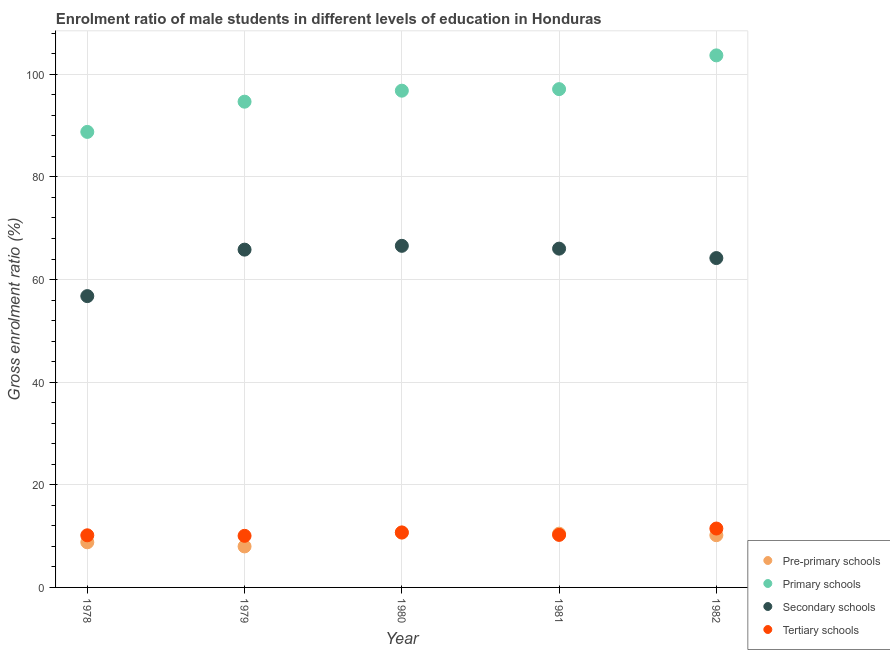How many different coloured dotlines are there?
Your response must be concise. 4. What is the gross enrolment ratio(female) in pre-primary schools in 1981?
Offer a terse response. 10.48. Across all years, what is the maximum gross enrolment ratio(female) in tertiary schools?
Provide a succinct answer. 11.48. Across all years, what is the minimum gross enrolment ratio(female) in pre-primary schools?
Provide a short and direct response. 7.99. In which year was the gross enrolment ratio(female) in primary schools minimum?
Your answer should be very brief. 1978. What is the total gross enrolment ratio(female) in tertiary schools in the graph?
Give a very brief answer. 52.64. What is the difference between the gross enrolment ratio(female) in secondary schools in 1980 and that in 1982?
Ensure brevity in your answer.  2.38. What is the difference between the gross enrolment ratio(female) in secondary schools in 1978 and the gross enrolment ratio(female) in pre-primary schools in 1980?
Your answer should be very brief. 46.09. What is the average gross enrolment ratio(female) in primary schools per year?
Your answer should be very brief. 96.21. In the year 1981, what is the difference between the gross enrolment ratio(female) in secondary schools and gross enrolment ratio(female) in primary schools?
Give a very brief answer. -31.09. In how many years, is the gross enrolment ratio(female) in pre-primary schools greater than 92 %?
Provide a succinct answer. 0. What is the ratio of the gross enrolment ratio(female) in pre-primary schools in 1980 to that in 1981?
Make the answer very short. 1.02. What is the difference between the highest and the second highest gross enrolment ratio(female) in tertiary schools?
Provide a short and direct response. 0.76. What is the difference between the highest and the lowest gross enrolment ratio(female) in tertiary schools?
Your response must be concise. 1.42. Is it the case that in every year, the sum of the gross enrolment ratio(female) in primary schools and gross enrolment ratio(female) in secondary schools is greater than the sum of gross enrolment ratio(female) in tertiary schools and gross enrolment ratio(female) in pre-primary schools?
Make the answer very short. Yes. Is it the case that in every year, the sum of the gross enrolment ratio(female) in pre-primary schools and gross enrolment ratio(female) in primary schools is greater than the gross enrolment ratio(female) in secondary schools?
Make the answer very short. Yes. Does the gross enrolment ratio(female) in pre-primary schools monotonically increase over the years?
Ensure brevity in your answer.  No. Is the gross enrolment ratio(female) in pre-primary schools strictly greater than the gross enrolment ratio(female) in primary schools over the years?
Provide a succinct answer. No. How many dotlines are there?
Give a very brief answer. 4. How many years are there in the graph?
Provide a succinct answer. 5. What is the difference between two consecutive major ticks on the Y-axis?
Keep it short and to the point. 20. Are the values on the major ticks of Y-axis written in scientific E-notation?
Make the answer very short. No. How many legend labels are there?
Keep it short and to the point. 4. What is the title of the graph?
Keep it short and to the point. Enrolment ratio of male students in different levels of education in Honduras. Does "Primary" appear as one of the legend labels in the graph?
Offer a very short reply. No. What is the label or title of the Y-axis?
Offer a very short reply. Gross enrolment ratio (%). What is the Gross enrolment ratio (%) of Pre-primary schools in 1978?
Offer a very short reply. 8.8. What is the Gross enrolment ratio (%) of Primary schools in 1978?
Offer a very short reply. 88.77. What is the Gross enrolment ratio (%) of Secondary schools in 1978?
Your response must be concise. 56.77. What is the Gross enrolment ratio (%) of Tertiary schools in 1978?
Your answer should be very brief. 10.16. What is the Gross enrolment ratio (%) in Pre-primary schools in 1979?
Give a very brief answer. 7.99. What is the Gross enrolment ratio (%) of Primary schools in 1979?
Offer a very short reply. 94.66. What is the Gross enrolment ratio (%) in Secondary schools in 1979?
Give a very brief answer. 65.83. What is the Gross enrolment ratio (%) in Tertiary schools in 1979?
Provide a succinct answer. 10.06. What is the Gross enrolment ratio (%) of Pre-primary schools in 1980?
Your response must be concise. 10.68. What is the Gross enrolment ratio (%) in Primary schools in 1980?
Offer a terse response. 96.81. What is the Gross enrolment ratio (%) of Secondary schools in 1980?
Your answer should be very brief. 66.57. What is the Gross enrolment ratio (%) of Tertiary schools in 1980?
Offer a very short reply. 10.71. What is the Gross enrolment ratio (%) in Pre-primary schools in 1981?
Your answer should be very brief. 10.48. What is the Gross enrolment ratio (%) in Primary schools in 1981?
Keep it short and to the point. 97.11. What is the Gross enrolment ratio (%) of Secondary schools in 1981?
Offer a terse response. 66.02. What is the Gross enrolment ratio (%) of Tertiary schools in 1981?
Ensure brevity in your answer.  10.24. What is the Gross enrolment ratio (%) of Pre-primary schools in 1982?
Provide a succinct answer. 10.18. What is the Gross enrolment ratio (%) of Primary schools in 1982?
Your answer should be very brief. 103.69. What is the Gross enrolment ratio (%) of Secondary schools in 1982?
Your answer should be very brief. 64.19. What is the Gross enrolment ratio (%) of Tertiary schools in 1982?
Ensure brevity in your answer.  11.48. Across all years, what is the maximum Gross enrolment ratio (%) in Pre-primary schools?
Offer a terse response. 10.68. Across all years, what is the maximum Gross enrolment ratio (%) of Primary schools?
Make the answer very short. 103.69. Across all years, what is the maximum Gross enrolment ratio (%) of Secondary schools?
Provide a succinct answer. 66.57. Across all years, what is the maximum Gross enrolment ratio (%) of Tertiary schools?
Ensure brevity in your answer.  11.48. Across all years, what is the minimum Gross enrolment ratio (%) in Pre-primary schools?
Offer a very short reply. 7.99. Across all years, what is the minimum Gross enrolment ratio (%) in Primary schools?
Your answer should be very brief. 88.77. Across all years, what is the minimum Gross enrolment ratio (%) of Secondary schools?
Keep it short and to the point. 56.77. Across all years, what is the minimum Gross enrolment ratio (%) of Tertiary schools?
Your response must be concise. 10.06. What is the total Gross enrolment ratio (%) of Pre-primary schools in the graph?
Offer a terse response. 48.12. What is the total Gross enrolment ratio (%) in Primary schools in the graph?
Give a very brief answer. 481.04. What is the total Gross enrolment ratio (%) of Secondary schools in the graph?
Give a very brief answer. 319.39. What is the total Gross enrolment ratio (%) of Tertiary schools in the graph?
Your answer should be compact. 52.64. What is the difference between the Gross enrolment ratio (%) in Pre-primary schools in 1978 and that in 1979?
Make the answer very short. 0.8. What is the difference between the Gross enrolment ratio (%) in Primary schools in 1978 and that in 1979?
Your answer should be very brief. -5.89. What is the difference between the Gross enrolment ratio (%) of Secondary schools in 1978 and that in 1979?
Your answer should be compact. -9.06. What is the difference between the Gross enrolment ratio (%) of Tertiary schools in 1978 and that in 1979?
Your answer should be very brief. 0.1. What is the difference between the Gross enrolment ratio (%) in Pre-primary schools in 1978 and that in 1980?
Your answer should be compact. -1.88. What is the difference between the Gross enrolment ratio (%) in Primary schools in 1978 and that in 1980?
Offer a very short reply. -8.03. What is the difference between the Gross enrolment ratio (%) of Secondary schools in 1978 and that in 1980?
Offer a terse response. -9.8. What is the difference between the Gross enrolment ratio (%) of Tertiary schools in 1978 and that in 1980?
Provide a short and direct response. -0.56. What is the difference between the Gross enrolment ratio (%) of Pre-primary schools in 1978 and that in 1981?
Offer a very short reply. -1.68. What is the difference between the Gross enrolment ratio (%) in Primary schools in 1978 and that in 1981?
Ensure brevity in your answer.  -8.34. What is the difference between the Gross enrolment ratio (%) in Secondary schools in 1978 and that in 1981?
Your response must be concise. -9.25. What is the difference between the Gross enrolment ratio (%) of Tertiary schools in 1978 and that in 1981?
Your answer should be compact. -0.08. What is the difference between the Gross enrolment ratio (%) in Pre-primary schools in 1978 and that in 1982?
Ensure brevity in your answer.  -1.38. What is the difference between the Gross enrolment ratio (%) in Primary schools in 1978 and that in 1982?
Your answer should be compact. -14.92. What is the difference between the Gross enrolment ratio (%) in Secondary schools in 1978 and that in 1982?
Provide a short and direct response. -7.41. What is the difference between the Gross enrolment ratio (%) in Tertiary schools in 1978 and that in 1982?
Provide a short and direct response. -1.32. What is the difference between the Gross enrolment ratio (%) in Pre-primary schools in 1979 and that in 1980?
Your answer should be compact. -2.69. What is the difference between the Gross enrolment ratio (%) in Primary schools in 1979 and that in 1980?
Offer a terse response. -2.14. What is the difference between the Gross enrolment ratio (%) in Secondary schools in 1979 and that in 1980?
Provide a succinct answer. -0.74. What is the difference between the Gross enrolment ratio (%) of Tertiary schools in 1979 and that in 1980?
Provide a short and direct response. -0.66. What is the difference between the Gross enrolment ratio (%) of Pre-primary schools in 1979 and that in 1981?
Your response must be concise. -2.49. What is the difference between the Gross enrolment ratio (%) of Primary schools in 1979 and that in 1981?
Your answer should be compact. -2.45. What is the difference between the Gross enrolment ratio (%) of Secondary schools in 1979 and that in 1981?
Your answer should be very brief. -0.19. What is the difference between the Gross enrolment ratio (%) in Tertiary schools in 1979 and that in 1981?
Make the answer very short. -0.18. What is the difference between the Gross enrolment ratio (%) in Pre-primary schools in 1979 and that in 1982?
Your answer should be compact. -2.19. What is the difference between the Gross enrolment ratio (%) in Primary schools in 1979 and that in 1982?
Provide a succinct answer. -9.02. What is the difference between the Gross enrolment ratio (%) in Secondary schools in 1979 and that in 1982?
Your response must be concise. 1.64. What is the difference between the Gross enrolment ratio (%) in Tertiary schools in 1979 and that in 1982?
Give a very brief answer. -1.42. What is the difference between the Gross enrolment ratio (%) in Pre-primary schools in 1980 and that in 1981?
Ensure brevity in your answer.  0.2. What is the difference between the Gross enrolment ratio (%) of Primary schools in 1980 and that in 1981?
Provide a succinct answer. -0.3. What is the difference between the Gross enrolment ratio (%) in Secondary schools in 1980 and that in 1981?
Provide a succinct answer. 0.55. What is the difference between the Gross enrolment ratio (%) of Tertiary schools in 1980 and that in 1981?
Your response must be concise. 0.48. What is the difference between the Gross enrolment ratio (%) of Pre-primary schools in 1980 and that in 1982?
Offer a terse response. 0.5. What is the difference between the Gross enrolment ratio (%) in Primary schools in 1980 and that in 1982?
Your answer should be very brief. -6.88. What is the difference between the Gross enrolment ratio (%) in Secondary schools in 1980 and that in 1982?
Keep it short and to the point. 2.38. What is the difference between the Gross enrolment ratio (%) of Tertiary schools in 1980 and that in 1982?
Give a very brief answer. -0.76. What is the difference between the Gross enrolment ratio (%) of Pre-primary schools in 1981 and that in 1982?
Give a very brief answer. 0.3. What is the difference between the Gross enrolment ratio (%) in Primary schools in 1981 and that in 1982?
Make the answer very short. -6.58. What is the difference between the Gross enrolment ratio (%) in Secondary schools in 1981 and that in 1982?
Your answer should be compact. 1.84. What is the difference between the Gross enrolment ratio (%) of Tertiary schools in 1981 and that in 1982?
Offer a terse response. -1.24. What is the difference between the Gross enrolment ratio (%) of Pre-primary schools in 1978 and the Gross enrolment ratio (%) of Primary schools in 1979?
Make the answer very short. -85.87. What is the difference between the Gross enrolment ratio (%) of Pre-primary schools in 1978 and the Gross enrolment ratio (%) of Secondary schools in 1979?
Ensure brevity in your answer.  -57.03. What is the difference between the Gross enrolment ratio (%) in Pre-primary schools in 1978 and the Gross enrolment ratio (%) in Tertiary schools in 1979?
Offer a terse response. -1.26. What is the difference between the Gross enrolment ratio (%) of Primary schools in 1978 and the Gross enrolment ratio (%) of Secondary schools in 1979?
Provide a short and direct response. 22.94. What is the difference between the Gross enrolment ratio (%) in Primary schools in 1978 and the Gross enrolment ratio (%) in Tertiary schools in 1979?
Give a very brief answer. 78.72. What is the difference between the Gross enrolment ratio (%) in Secondary schools in 1978 and the Gross enrolment ratio (%) in Tertiary schools in 1979?
Ensure brevity in your answer.  46.72. What is the difference between the Gross enrolment ratio (%) in Pre-primary schools in 1978 and the Gross enrolment ratio (%) in Primary schools in 1980?
Keep it short and to the point. -88.01. What is the difference between the Gross enrolment ratio (%) in Pre-primary schools in 1978 and the Gross enrolment ratio (%) in Secondary schools in 1980?
Give a very brief answer. -57.78. What is the difference between the Gross enrolment ratio (%) of Pre-primary schools in 1978 and the Gross enrolment ratio (%) of Tertiary schools in 1980?
Offer a terse response. -1.92. What is the difference between the Gross enrolment ratio (%) of Primary schools in 1978 and the Gross enrolment ratio (%) of Secondary schools in 1980?
Your answer should be very brief. 22.2. What is the difference between the Gross enrolment ratio (%) in Primary schools in 1978 and the Gross enrolment ratio (%) in Tertiary schools in 1980?
Your answer should be very brief. 78.06. What is the difference between the Gross enrolment ratio (%) of Secondary schools in 1978 and the Gross enrolment ratio (%) of Tertiary schools in 1980?
Provide a short and direct response. 46.06. What is the difference between the Gross enrolment ratio (%) in Pre-primary schools in 1978 and the Gross enrolment ratio (%) in Primary schools in 1981?
Your answer should be very brief. -88.31. What is the difference between the Gross enrolment ratio (%) of Pre-primary schools in 1978 and the Gross enrolment ratio (%) of Secondary schools in 1981?
Offer a terse response. -57.23. What is the difference between the Gross enrolment ratio (%) of Pre-primary schools in 1978 and the Gross enrolment ratio (%) of Tertiary schools in 1981?
Offer a very short reply. -1.44. What is the difference between the Gross enrolment ratio (%) in Primary schools in 1978 and the Gross enrolment ratio (%) in Secondary schools in 1981?
Your answer should be very brief. 22.75. What is the difference between the Gross enrolment ratio (%) in Primary schools in 1978 and the Gross enrolment ratio (%) in Tertiary schools in 1981?
Provide a short and direct response. 78.54. What is the difference between the Gross enrolment ratio (%) in Secondary schools in 1978 and the Gross enrolment ratio (%) in Tertiary schools in 1981?
Provide a short and direct response. 46.54. What is the difference between the Gross enrolment ratio (%) in Pre-primary schools in 1978 and the Gross enrolment ratio (%) in Primary schools in 1982?
Your answer should be very brief. -94.89. What is the difference between the Gross enrolment ratio (%) of Pre-primary schools in 1978 and the Gross enrolment ratio (%) of Secondary schools in 1982?
Ensure brevity in your answer.  -55.39. What is the difference between the Gross enrolment ratio (%) of Pre-primary schools in 1978 and the Gross enrolment ratio (%) of Tertiary schools in 1982?
Offer a very short reply. -2.68. What is the difference between the Gross enrolment ratio (%) in Primary schools in 1978 and the Gross enrolment ratio (%) in Secondary schools in 1982?
Offer a terse response. 24.59. What is the difference between the Gross enrolment ratio (%) in Primary schools in 1978 and the Gross enrolment ratio (%) in Tertiary schools in 1982?
Offer a very short reply. 77.3. What is the difference between the Gross enrolment ratio (%) of Secondary schools in 1978 and the Gross enrolment ratio (%) of Tertiary schools in 1982?
Offer a terse response. 45.3. What is the difference between the Gross enrolment ratio (%) of Pre-primary schools in 1979 and the Gross enrolment ratio (%) of Primary schools in 1980?
Ensure brevity in your answer.  -88.82. What is the difference between the Gross enrolment ratio (%) in Pre-primary schools in 1979 and the Gross enrolment ratio (%) in Secondary schools in 1980?
Your response must be concise. -58.58. What is the difference between the Gross enrolment ratio (%) in Pre-primary schools in 1979 and the Gross enrolment ratio (%) in Tertiary schools in 1980?
Ensure brevity in your answer.  -2.72. What is the difference between the Gross enrolment ratio (%) in Primary schools in 1979 and the Gross enrolment ratio (%) in Secondary schools in 1980?
Your response must be concise. 28.09. What is the difference between the Gross enrolment ratio (%) in Primary schools in 1979 and the Gross enrolment ratio (%) in Tertiary schools in 1980?
Give a very brief answer. 83.95. What is the difference between the Gross enrolment ratio (%) in Secondary schools in 1979 and the Gross enrolment ratio (%) in Tertiary schools in 1980?
Ensure brevity in your answer.  55.12. What is the difference between the Gross enrolment ratio (%) of Pre-primary schools in 1979 and the Gross enrolment ratio (%) of Primary schools in 1981?
Your response must be concise. -89.12. What is the difference between the Gross enrolment ratio (%) of Pre-primary schools in 1979 and the Gross enrolment ratio (%) of Secondary schools in 1981?
Offer a terse response. -58.03. What is the difference between the Gross enrolment ratio (%) of Pre-primary schools in 1979 and the Gross enrolment ratio (%) of Tertiary schools in 1981?
Offer a very short reply. -2.25. What is the difference between the Gross enrolment ratio (%) in Primary schools in 1979 and the Gross enrolment ratio (%) in Secondary schools in 1981?
Offer a very short reply. 28.64. What is the difference between the Gross enrolment ratio (%) in Primary schools in 1979 and the Gross enrolment ratio (%) in Tertiary schools in 1981?
Offer a terse response. 84.43. What is the difference between the Gross enrolment ratio (%) of Secondary schools in 1979 and the Gross enrolment ratio (%) of Tertiary schools in 1981?
Your answer should be compact. 55.59. What is the difference between the Gross enrolment ratio (%) of Pre-primary schools in 1979 and the Gross enrolment ratio (%) of Primary schools in 1982?
Make the answer very short. -95.7. What is the difference between the Gross enrolment ratio (%) of Pre-primary schools in 1979 and the Gross enrolment ratio (%) of Secondary schools in 1982?
Your response must be concise. -56.2. What is the difference between the Gross enrolment ratio (%) of Pre-primary schools in 1979 and the Gross enrolment ratio (%) of Tertiary schools in 1982?
Offer a very short reply. -3.49. What is the difference between the Gross enrolment ratio (%) of Primary schools in 1979 and the Gross enrolment ratio (%) of Secondary schools in 1982?
Offer a terse response. 30.48. What is the difference between the Gross enrolment ratio (%) of Primary schools in 1979 and the Gross enrolment ratio (%) of Tertiary schools in 1982?
Provide a short and direct response. 83.19. What is the difference between the Gross enrolment ratio (%) in Secondary schools in 1979 and the Gross enrolment ratio (%) in Tertiary schools in 1982?
Offer a terse response. 54.35. What is the difference between the Gross enrolment ratio (%) in Pre-primary schools in 1980 and the Gross enrolment ratio (%) in Primary schools in 1981?
Provide a succinct answer. -86.43. What is the difference between the Gross enrolment ratio (%) in Pre-primary schools in 1980 and the Gross enrolment ratio (%) in Secondary schools in 1981?
Your answer should be compact. -55.34. What is the difference between the Gross enrolment ratio (%) in Pre-primary schools in 1980 and the Gross enrolment ratio (%) in Tertiary schools in 1981?
Give a very brief answer. 0.44. What is the difference between the Gross enrolment ratio (%) of Primary schools in 1980 and the Gross enrolment ratio (%) of Secondary schools in 1981?
Offer a very short reply. 30.78. What is the difference between the Gross enrolment ratio (%) of Primary schools in 1980 and the Gross enrolment ratio (%) of Tertiary schools in 1981?
Keep it short and to the point. 86.57. What is the difference between the Gross enrolment ratio (%) of Secondary schools in 1980 and the Gross enrolment ratio (%) of Tertiary schools in 1981?
Your answer should be compact. 56.34. What is the difference between the Gross enrolment ratio (%) in Pre-primary schools in 1980 and the Gross enrolment ratio (%) in Primary schools in 1982?
Offer a terse response. -93.01. What is the difference between the Gross enrolment ratio (%) of Pre-primary schools in 1980 and the Gross enrolment ratio (%) of Secondary schools in 1982?
Make the answer very short. -53.51. What is the difference between the Gross enrolment ratio (%) of Pre-primary schools in 1980 and the Gross enrolment ratio (%) of Tertiary schools in 1982?
Give a very brief answer. -0.8. What is the difference between the Gross enrolment ratio (%) in Primary schools in 1980 and the Gross enrolment ratio (%) in Secondary schools in 1982?
Provide a short and direct response. 32.62. What is the difference between the Gross enrolment ratio (%) in Primary schools in 1980 and the Gross enrolment ratio (%) in Tertiary schools in 1982?
Give a very brief answer. 85.33. What is the difference between the Gross enrolment ratio (%) of Secondary schools in 1980 and the Gross enrolment ratio (%) of Tertiary schools in 1982?
Give a very brief answer. 55.09. What is the difference between the Gross enrolment ratio (%) of Pre-primary schools in 1981 and the Gross enrolment ratio (%) of Primary schools in 1982?
Make the answer very short. -93.21. What is the difference between the Gross enrolment ratio (%) in Pre-primary schools in 1981 and the Gross enrolment ratio (%) in Secondary schools in 1982?
Your response must be concise. -53.71. What is the difference between the Gross enrolment ratio (%) in Pre-primary schools in 1981 and the Gross enrolment ratio (%) in Tertiary schools in 1982?
Your response must be concise. -1. What is the difference between the Gross enrolment ratio (%) in Primary schools in 1981 and the Gross enrolment ratio (%) in Secondary schools in 1982?
Keep it short and to the point. 32.92. What is the difference between the Gross enrolment ratio (%) in Primary schools in 1981 and the Gross enrolment ratio (%) in Tertiary schools in 1982?
Your answer should be compact. 85.63. What is the difference between the Gross enrolment ratio (%) in Secondary schools in 1981 and the Gross enrolment ratio (%) in Tertiary schools in 1982?
Offer a very short reply. 54.55. What is the average Gross enrolment ratio (%) in Pre-primary schools per year?
Give a very brief answer. 9.62. What is the average Gross enrolment ratio (%) of Primary schools per year?
Offer a terse response. 96.21. What is the average Gross enrolment ratio (%) of Secondary schools per year?
Your answer should be compact. 63.88. What is the average Gross enrolment ratio (%) in Tertiary schools per year?
Offer a terse response. 10.53. In the year 1978, what is the difference between the Gross enrolment ratio (%) of Pre-primary schools and Gross enrolment ratio (%) of Primary schools?
Make the answer very short. -79.98. In the year 1978, what is the difference between the Gross enrolment ratio (%) of Pre-primary schools and Gross enrolment ratio (%) of Secondary schools?
Ensure brevity in your answer.  -47.98. In the year 1978, what is the difference between the Gross enrolment ratio (%) of Pre-primary schools and Gross enrolment ratio (%) of Tertiary schools?
Ensure brevity in your answer.  -1.36. In the year 1978, what is the difference between the Gross enrolment ratio (%) of Primary schools and Gross enrolment ratio (%) of Secondary schools?
Offer a very short reply. 32. In the year 1978, what is the difference between the Gross enrolment ratio (%) of Primary schools and Gross enrolment ratio (%) of Tertiary schools?
Ensure brevity in your answer.  78.61. In the year 1978, what is the difference between the Gross enrolment ratio (%) of Secondary schools and Gross enrolment ratio (%) of Tertiary schools?
Offer a terse response. 46.62. In the year 1979, what is the difference between the Gross enrolment ratio (%) in Pre-primary schools and Gross enrolment ratio (%) in Primary schools?
Give a very brief answer. -86.67. In the year 1979, what is the difference between the Gross enrolment ratio (%) in Pre-primary schools and Gross enrolment ratio (%) in Secondary schools?
Give a very brief answer. -57.84. In the year 1979, what is the difference between the Gross enrolment ratio (%) in Pre-primary schools and Gross enrolment ratio (%) in Tertiary schools?
Give a very brief answer. -2.06. In the year 1979, what is the difference between the Gross enrolment ratio (%) of Primary schools and Gross enrolment ratio (%) of Secondary schools?
Provide a succinct answer. 28.83. In the year 1979, what is the difference between the Gross enrolment ratio (%) in Primary schools and Gross enrolment ratio (%) in Tertiary schools?
Your response must be concise. 84.61. In the year 1979, what is the difference between the Gross enrolment ratio (%) in Secondary schools and Gross enrolment ratio (%) in Tertiary schools?
Provide a succinct answer. 55.77. In the year 1980, what is the difference between the Gross enrolment ratio (%) of Pre-primary schools and Gross enrolment ratio (%) of Primary schools?
Ensure brevity in your answer.  -86.13. In the year 1980, what is the difference between the Gross enrolment ratio (%) in Pre-primary schools and Gross enrolment ratio (%) in Secondary schools?
Keep it short and to the point. -55.89. In the year 1980, what is the difference between the Gross enrolment ratio (%) in Pre-primary schools and Gross enrolment ratio (%) in Tertiary schools?
Provide a succinct answer. -0.03. In the year 1980, what is the difference between the Gross enrolment ratio (%) in Primary schools and Gross enrolment ratio (%) in Secondary schools?
Offer a very short reply. 30.24. In the year 1980, what is the difference between the Gross enrolment ratio (%) in Primary schools and Gross enrolment ratio (%) in Tertiary schools?
Ensure brevity in your answer.  86.09. In the year 1980, what is the difference between the Gross enrolment ratio (%) of Secondary schools and Gross enrolment ratio (%) of Tertiary schools?
Offer a very short reply. 55.86. In the year 1981, what is the difference between the Gross enrolment ratio (%) of Pre-primary schools and Gross enrolment ratio (%) of Primary schools?
Ensure brevity in your answer.  -86.63. In the year 1981, what is the difference between the Gross enrolment ratio (%) of Pre-primary schools and Gross enrolment ratio (%) of Secondary schools?
Give a very brief answer. -55.55. In the year 1981, what is the difference between the Gross enrolment ratio (%) in Pre-primary schools and Gross enrolment ratio (%) in Tertiary schools?
Offer a terse response. 0.24. In the year 1981, what is the difference between the Gross enrolment ratio (%) in Primary schools and Gross enrolment ratio (%) in Secondary schools?
Offer a terse response. 31.09. In the year 1981, what is the difference between the Gross enrolment ratio (%) of Primary schools and Gross enrolment ratio (%) of Tertiary schools?
Your answer should be compact. 86.87. In the year 1981, what is the difference between the Gross enrolment ratio (%) in Secondary schools and Gross enrolment ratio (%) in Tertiary schools?
Your answer should be very brief. 55.79. In the year 1982, what is the difference between the Gross enrolment ratio (%) of Pre-primary schools and Gross enrolment ratio (%) of Primary schools?
Offer a very short reply. -93.51. In the year 1982, what is the difference between the Gross enrolment ratio (%) of Pre-primary schools and Gross enrolment ratio (%) of Secondary schools?
Your answer should be very brief. -54.01. In the year 1982, what is the difference between the Gross enrolment ratio (%) in Pre-primary schools and Gross enrolment ratio (%) in Tertiary schools?
Make the answer very short. -1.3. In the year 1982, what is the difference between the Gross enrolment ratio (%) of Primary schools and Gross enrolment ratio (%) of Secondary schools?
Your answer should be compact. 39.5. In the year 1982, what is the difference between the Gross enrolment ratio (%) in Primary schools and Gross enrolment ratio (%) in Tertiary schools?
Offer a terse response. 92.21. In the year 1982, what is the difference between the Gross enrolment ratio (%) in Secondary schools and Gross enrolment ratio (%) in Tertiary schools?
Offer a terse response. 52.71. What is the ratio of the Gross enrolment ratio (%) in Pre-primary schools in 1978 to that in 1979?
Your answer should be compact. 1.1. What is the ratio of the Gross enrolment ratio (%) in Primary schools in 1978 to that in 1979?
Offer a very short reply. 0.94. What is the ratio of the Gross enrolment ratio (%) in Secondary schools in 1978 to that in 1979?
Your answer should be very brief. 0.86. What is the ratio of the Gross enrolment ratio (%) of Tertiary schools in 1978 to that in 1979?
Ensure brevity in your answer.  1.01. What is the ratio of the Gross enrolment ratio (%) in Pre-primary schools in 1978 to that in 1980?
Provide a short and direct response. 0.82. What is the ratio of the Gross enrolment ratio (%) of Primary schools in 1978 to that in 1980?
Offer a very short reply. 0.92. What is the ratio of the Gross enrolment ratio (%) of Secondary schools in 1978 to that in 1980?
Offer a terse response. 0.85. What is the ratio of the Gross enrolment ratio (%) of Tertiary schools in 1978 to that in 1980?
Your answer should be very brief. 0.95. What is the ratio of the Gross enrolment ratio (%) in Pre-primary schools in 1978 to that in 1981?
Your response must be concise. 0.84. What is the ratio of the Gross enrolment ratio (%) of Primary schools in 1978 to that in 1981?
Offer a terse response. 0.91. What is the ratio of the Gross enrolment ratio (%) of Secondary schools in 1978 to that in 1981?
Give a very brief answer. 0.86. What is the ratio of the Gross enrolment ratio (%) in Tertiary schools in 1978 to that in 1981?
Your answer should be very brief. 0.99. What is the ratio of the Gross enrolment ratio (%) of Pre-primary schools in 1978 to that in 1982?
Offer a terse response. 0.86. What is the ratio of the Gross enrolment ratio (%) of Primary schools in 1978 to that in 1982?
Provide a short and direct response. 0.86. What is the ratio of the Gross enrolment ratio (%) of Secondary schools in 1978 to that in 1982?
Give a very brief answer. 0.88. What is the ratio of the Gross enrolment ratio (%) of Tertiary schools in 1978 to that in 1982?
Offer a very short reply. 0.89. What is the ratio of the Gross enrolment ratio (%) in Pre-primary schools in 1979 to that in 1980?
Your response must be concise. 0.75. What is the ratio of the Gross enrolment ratio (%) of Primary schools in 1979 to that in 1980?
Your answer should be very brief. 0.98. What is the ratio of the Gross enrolment ratio (%) in Secondary schools in 1979 to that in 1980?
Offer a very short reply. 0.99. What is the ratio of the Gross enrolment ratio (%) in Tertiary schools in 1979 to that in 1980?
Keep it short and to the point. 0.94. What is the ratio of the Gross enrolment ratio (%) in Pre-primary schools in 1979 to that in 1981?
Offer a very short reply. 0.76. What is the ratio of the Gross enrolment ratio (%) of Primary schools in 1979 to that in 1981?
Keep it short and to the point. 0.97. What is the ratio of the Gross enrolment ratio (%) of Secondary schools in 1979 to that in 1981?
Your answer should be very brief. 1. What is the ratio of the Gross enrolment ratio (%) in Tertiary schools in 1979 to that in 1981?
Offer a very short reply. 0.98. What is the ratio of the Gross enrolment ratio (%) in Pre-primary schools in 1979 to that in 1982?
Make the answer very short. 0.79. What is the ratio of the Gross enrolment ratio (%) of Primary schools in 1979 to that in 1982?
Offer a terse response. 0.91. What is the ratio of the Gross enrolment ratio (%) in Secondary schools in 1979 to that in 1982?
Your answer should be compact. 1.03. What is the ratio of the Gross enrolment ratio (%) of Tertiary schools in 1979 to that in 1982?
Your answer should be compact. 0.88. What is the ratio of the Gross enrolment ratio (%) in Pre-primary schools in 1980 to that in 1981?
Give a very brief answer. 1.02. What is the ratio of the Gross enrolment ratio (%) of Secondary schools in 1980 to that in 1981?
Your response must be concise. 1.01. What is the ratio of the Gross enrolment ratio (%) of Tertiary schools in 1980 to that in 1981?
Give a very brief answer. 1.05. What is the ratio of the Gross enrolment ratio (%) of Pre-primary schools in 1980 to that in 1982?
Give a very brief answer. 1.05. What is the ratio of the Gross enrolment ratio (%) in Primary schools in 1980 to that in 1982?
Ensure brevity in your answer.  0.93. What is the ratio of the Gross enrolment ratio (%) in Secondary schools in 1980 to that in 1982?
Ensure brevity in your answer.  1.04. What is the ratio of the Gross enrolment ratio (%) in Tertiary schools in 1980 to that in 1982?
Your answer should be very brief. 0.93. What is the ratio of the Gross enrolment ratio (%) in Pre-primary schools in 1981 to that in 1982?
Provide a succinct answer. 1.03. What is the ratio of the Gross enrolment ratio (%) of Primary schools in 1981 to that in 1982?
Your response must be concise. 0.94. What is the ratio of the Gross enrolment ratio (%) in Secondary schools in 1981 to that in 1982?
Provide a short and direct response. 1.03. What is the ratio of the Gross enrolment ratio (%) in Tertiary schools in 1981 to that in 1982?
Your answer should be very brief. 0.89. What is the difference between the highest and the second highest Gross enrolment ratio (%) of Pre-primary schools?
Ensure brevity in your answer.  0.2. What is the difference between the highest and the second highest Gross enrolment ratio (%) of Primary schools?
Ensure brevity in your answer.  6.58. What is the difference between the highest and the second highest Gross enrolment ratio (%) in Secondary schools?
Provide a succinct answer. 0.55. What is the difference between the highest and the second highest Gross enrolment ratio (%) of Tertiary schools?
Offer a terse response. 0.76. What is the difference between the highest and the lowest Gross enrolment ratio (%) of Pre-primary schools?
Offer a very short reply. 2.69. What is the difference between the highest and the lowest Gross enrolment ratio (%) of Primary schools?
Keep it short and to the point. 14.92. What is the difference between the highest and the lowest Gross enrolment ratio (%) of Secondary schools?
Make the answer very short. 9.8. What is the difference between the highest and the lowest Gross enrolment ratio (%) of Tertiary schools?
Provide a short and direct response. 1.42. 